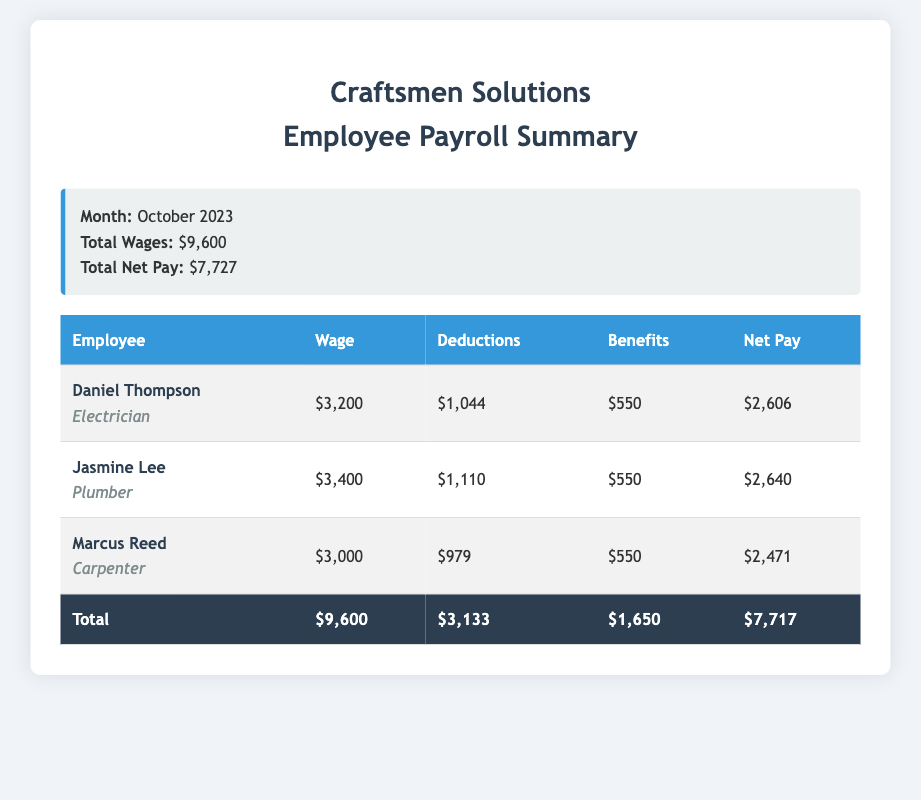What month is this payroll summary for? The payroll summary indicates it is for October 2023.
Answer: October 2023 What is the total wages amount? The document states the total wages are $9,600.
Answer: $9,600 How much was deducted from Jasmine Lee's wages? The document shows that Jasmine Lee had $1,110 in deductions.
Answer: $1,110 What position does Marcus Reed hold? The document specifies that Marcus Reed is a carpenter.
Answer: Carpenter What is the total net pay for all employees? The total net pay is shown as $7,727 in the document.
Answer: $7,727 How much in benefits is provided to Daniel Thompson? The document indicates that Daniel Thompson receives $550 in benefits.
Answer: $550 What was the net pay for the plumber? The document states that the net pay for Jasmine Lee, the plumber, is $2,640.
Answer: $2,640 What is the total amount of deductions across all employees? The total deductions across all employees is $3,133 as mentioned in the document.
Answer: $3,133 What is the name of the electrician? The document lists Daniel Thompson as the electrician.
Answer: Daniel Thompson 